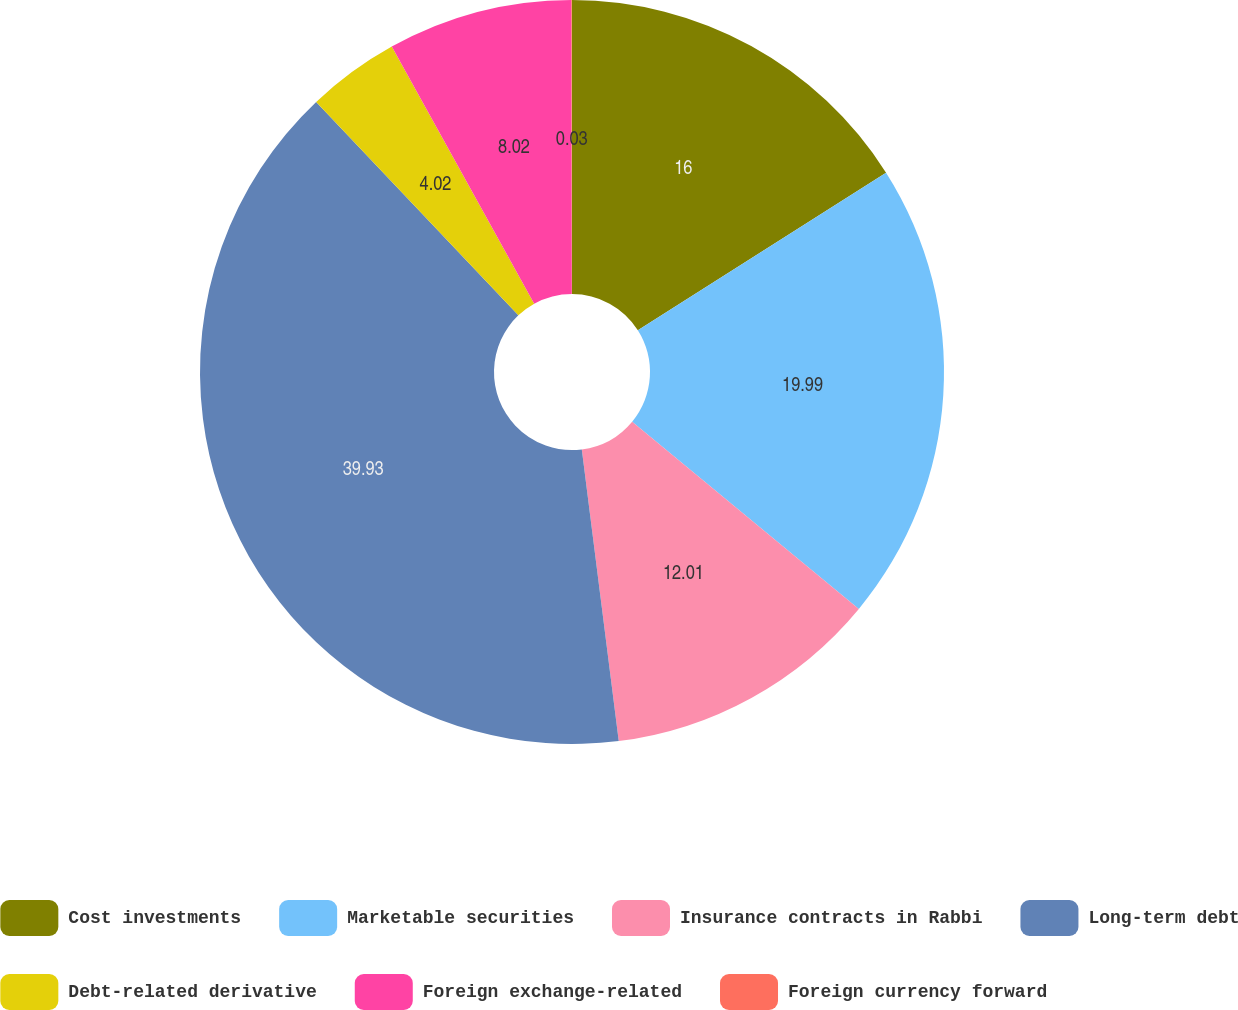Convert chart. <chart><loc_0><loc_0><loc_500><loc_500><pie_chart><fcel>Cost investments<fcel>Marketable securities<fcel>Insurance contracts in Rabbi<fcel>Long-term debt<fcel>Debt-related derivative<fcel>Foreign exchange-related<fcel>Foreign currency forward<nl><fcel>16.0%<fcel>19.99%<fcel>12.01%<fcel>39.94%<fcel>4.02%<fcel>8.02%<fcel>0.03%<nl></chart> 